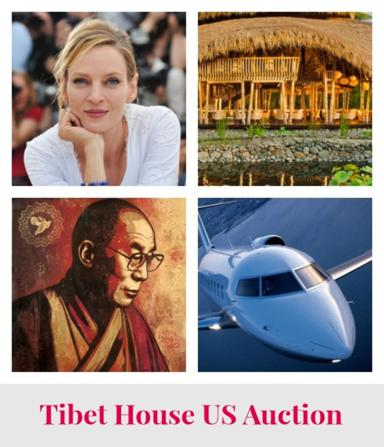How does the image of the airplane relate to the themes of the Tibet House US Auction? The airplane symbolizes the global nature of the Tibet House US Auction, reflecting the travel opportunities or experiences that might be available for bidding. It represents the broader reach of the auction, potentially attracting international attention and support. 